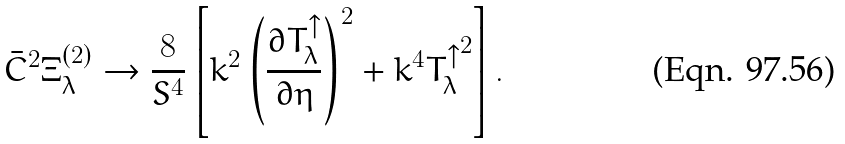<formula> <loc_0><loc_0><loc_500><loc_500>\bar { C } ^ { 2 } \Xi ^ { ( 2 ) } _ { \lambda } \to \frac { 8 } { S ^ { 4 } } \left [ k ^ { 2 } \left ( { \frac { \partial T ^ { \uparrow } _ { \lambda } } { \partial \eta } } \right ) ^ { 2 } + k ^ { 4 } { T ^ { \uparrow } _ { \lambda } } ^ { 2 } \right ] .</formula> 